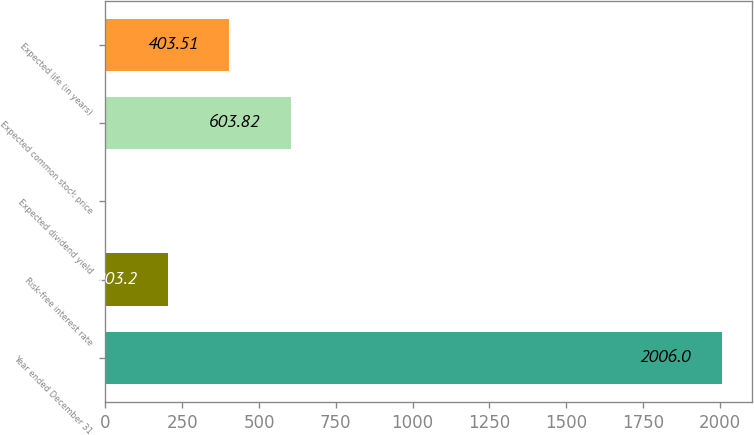Convert chart to OTSL. <chart><loc_0><loc_0><loc_500><loc_500><bar_chart><fcel>Year ended December 31<fcel>Risk-free interest rate<fcel>Expected dividend yield<fcel>Expected common stock price<fcel>Expected life (in years)<nl><fcel>2006<fcel>203.2<fcel>2.89<fcel>603.82<fcel>403.51<nl></chart> 